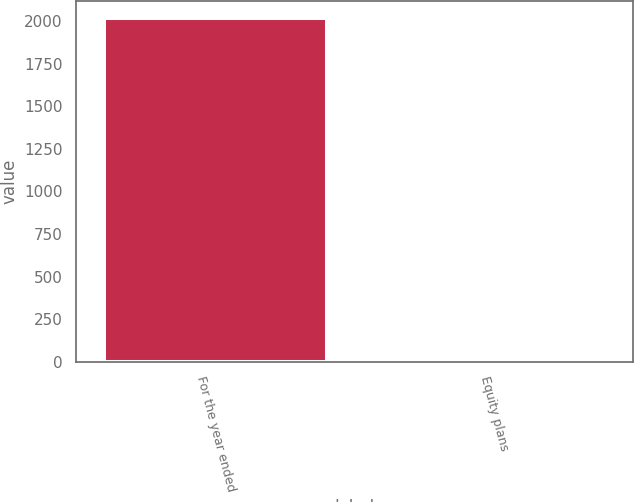<chart> <loc_0><loc_0><loc_500><loc_500><bar_chart><fcel>For the year ended<fcel>Equity plans<nl><fcel>2017<fcel>21<nl></chart> 